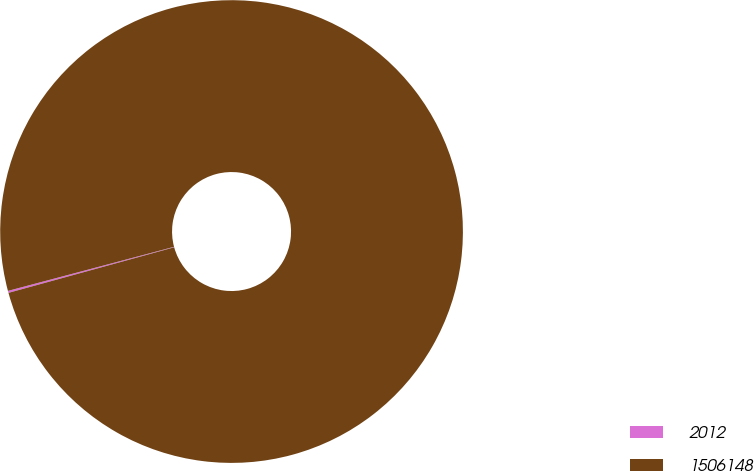<chart> <loc_0><loc_0><loc_500><loc_500><pie_chart><fcel>2012<fcel>1506148<nl><fcel>0.14%<fcel>99.86%<nl></chart> 